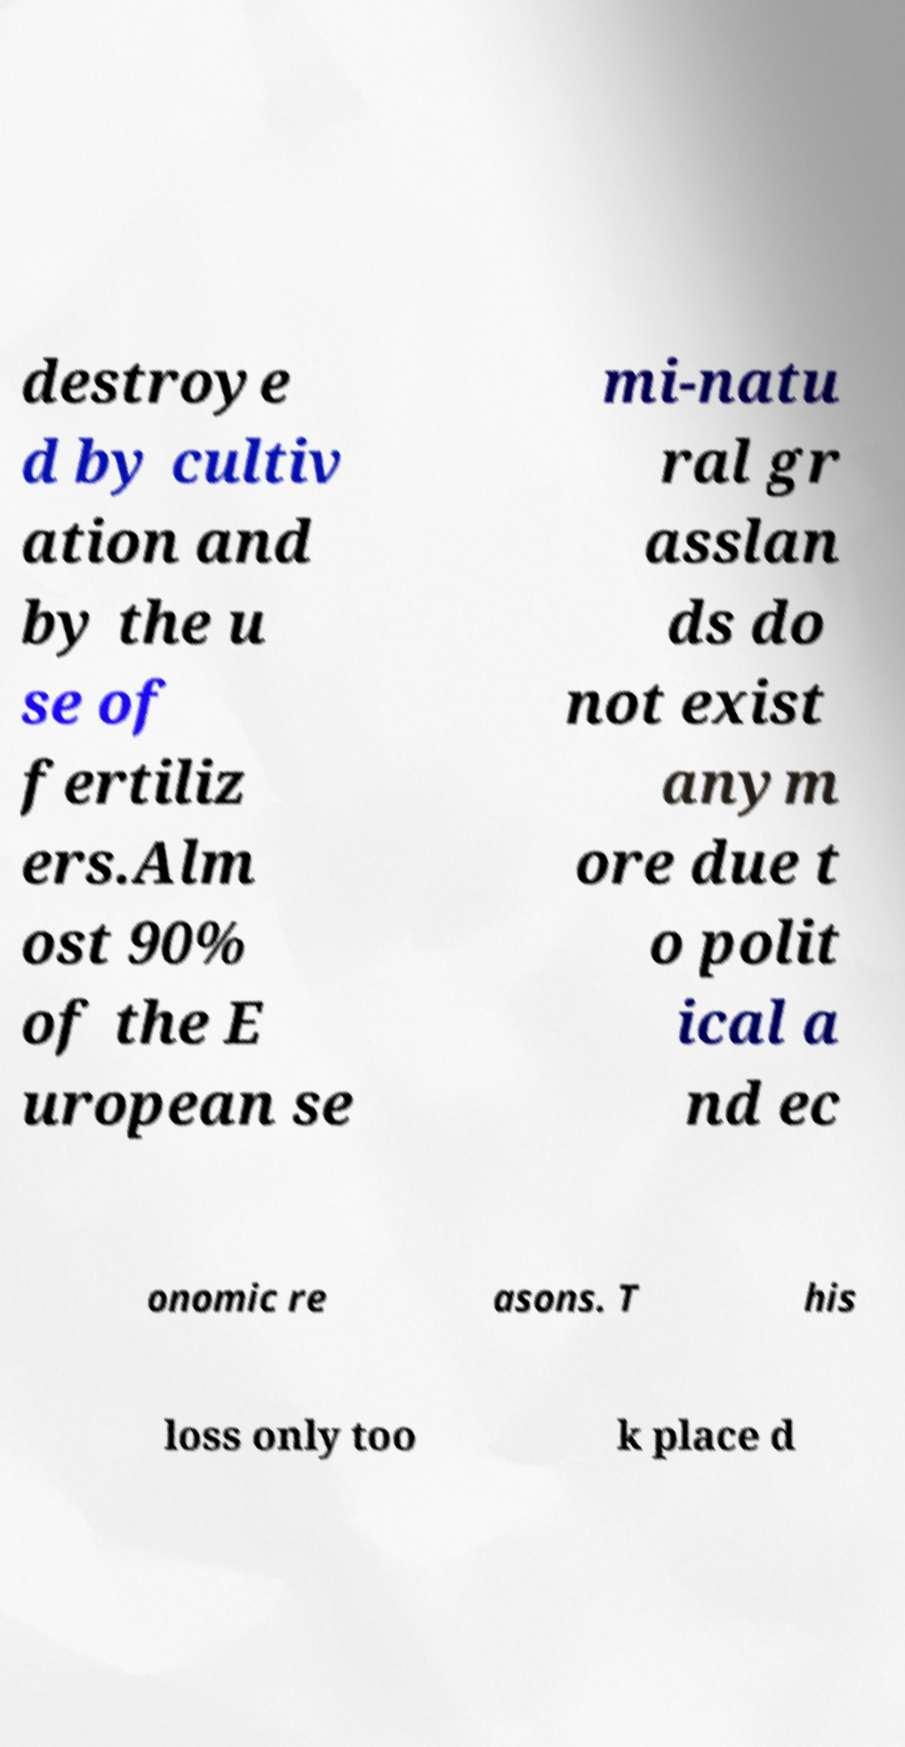I need the written content from this picture converted into text. Can you do that? destroye d by cultiv ation and by the u se of fertiliz ers.Alm ost 90% of the E uropean se mi-natu ral gr asslan ds do not exist anym ore due t o polit ical a nd ec onomic re asons. T his loss only too k place d 